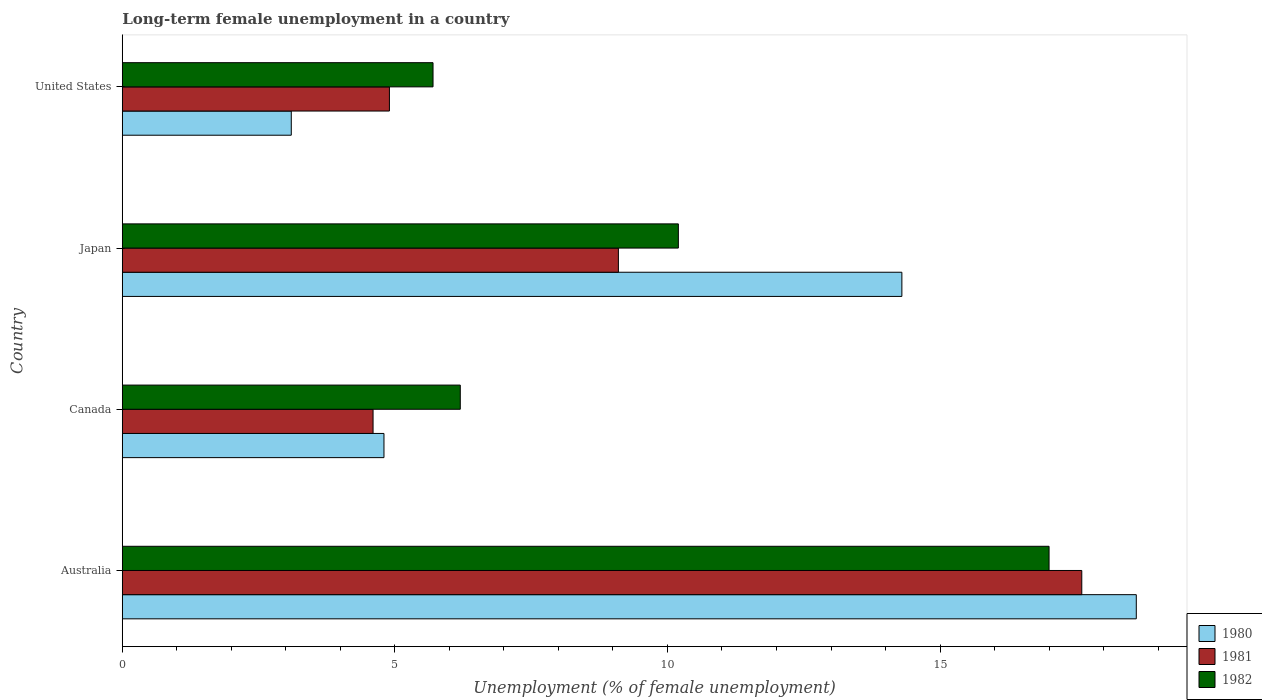Are the number of bars per tick equal to the number of legend labels?
Provide a short and direct response. Yes. Are the number of bars on each tick of the Y-axis equal?
Give a very brief answer. Yes. How many bars are there on the 2nd tick from the top?
Keep it short and to the point. 3. In how many cases, is the number of bars for a given country not equal to the number of legend labels?
Ensure brevity in your answer.  0. What is the percentage of long-term unemployed female population in 1980 in Canada?
Keep it short and to the point. 4.8. Across all countries, what is the maximum percentage of long-term unemployed female population in 1980?
Ensure brevity in your answer.  18.6. Across all countries, what is the minimum percentage of long-term unemployed female population in 1981?
Give a very brief answer. 4.6. In which country was the percentage of long-term unemployed female population in 1981 maximum?
Offer a terse response. Australia. What is the total percentage of long-term unemployed female population in 1981 in the graph?
Provide a succinct answer. 36.2. What is the difference between the percentage of long-term unemployed female population in 1981 in Australia and that in Japan?
Your answer should be compact. 8.5. What is the difference between the percentage of long-term unemployed female population in 1982 in United States and the percentage of long-term unemployed female population in 1980 in Australia?
Keep it short and to the point. -12.9. What is the average percentage of long-term unemployed female population in 1981 per country?
Give a very brief answer. 9.05. What is the difference between the percentage of long-term unemployed female population in 1981 and percentage of long-term unemployed female population in 1982 in Australia?
Provide a succinct answer. 0.6. In how many countries, is the percentage of long-term unemployed female population in 1981 greater than 10 %?
Keep it short and to the point. 1. What is the ratio of the percentage of long-term unemployed female population in 1980 in Australia to that in Japan?
Make the answer very short. 1.3. Is the percentage of long-term unemployed female population in 1980 in Canada less than that in Japan?
Make the answer very short. Yes. What is the difference between the highest and the second highest percentage of long-term unemployed female population in 1981?
Offer a very short reply. 8.5. What is the difference between the highest and the lowest percentage of long-term unemployed female population in 1981?
Keep it short and to the point. 13. In how many countries, is the percentage of long-term unemployed female population in 1982 greater than the average percentage of long-term unemployed female population in 1982 taken over all countries?
Provide a succinct answer. 2. Is the sum of the percentage of long-term unemployed female population in 1981 in Japan and United States greater than the maximum percentage of long-term unemployed female population in 1982 across all countries?
Your answer should be compact. No. Is it the case that in every country, the sum of the percentage of long-term unemployed female population in 1981 and percentage of long-term unemployed female population in 1982 is greater than the percentage of long-term unemployed female population in 1980?
Make the answer very short. Yes. Are all the bars in the graph horizontal?
Offer a terse response. Yes. How many countries are there in the graph?
Make the answer very short. 4. Where does the legend appear in the graph?
Give a very brief answer. Bottom right. How many legend labels are there?
Your answer should be very brief. 3. How are the legend labels stacked?
Your answer should be compact. Vertical. What is the title of the graph?
Ensure brevity in your answer.  Long-term female unemployment in a country. Does "2005" appear as one of the legend labels in the graph?
Provide a succinct answer. No. What is the label or title of the X-axis?
Your answer should be very brief. Unemployment (% of female unemployment). What is the Unemployment (% of female unemployment) of 1980 in Australia?
Offer a terse response. 18.6. What is the Unemployment (% of female unemployment) in 1981 in Australia?
Offer a very short reply. 17.6. What is the Unemployment (% of female unemployment) of 1980 in Canada?
Make the answer very short. 4.8. What is the Unemployment (% of female unemployment) of 1981 in Canada?
Give a very brief answer. 4.6. What is the Unemployment (% of female unemployment) of 1982 in Canada?
Provide a succinct answer. 6.2. What is the Unemployment (% of female unemployment) of 1980 in Japan?
Ensure brevity in your answer.  14.3. What is the Unemployment (% of female unemployment) in 1981 in Japan?
Your answer should be compact. 9.1. What is the Unemployment (% of female unemployment) of 1982 in Japan?
Keep it short and to the point. 10.2. What is the Unemployment (% of female unemployment) of 1980 in United States?
Your answer should be compact. 3.1. What is the Unemployment (% of female unemployment) in 1981 in United States?
Offer a very short reply. 4.9. What is the Unemployment (% of female unemployment) of 1982 in United States?
Your response must be concise. 5.7. Across all countries, what is the maximum Unemployment (% of female unemployment) of 1980?
Your answer should be very brief. 18.6. Across all countries, what is the maximum Unemployment (% of female unemployment) of 1981?
Give a very brief answer. 17.6. Across all countries, what is the minimum Unemployment (% of female unemployment) in 1980?
Give a very brief answer. 3.1. Across all countries, what is the minimum Unemployment (% of female unemployment) of 1981?
Provide a succinct answer. 4.6. Across all countries, what is the minimum Unemployment (% of female unemployment) in 1982?
Make the answer very short. 5.7. What is the total Unemployment (% of female unemployment) in 1980 in the graph?
Give a very brief answer. 40.8. What is the total Unemployment (% of female unemployment) of 1981 in the graph?
Your answer should be compact. 36.2. What is the total Unemployment (% of female unemployment) in 1982 in the graph?
Offer a terse response. 39.1. What is the difference between the Unemployment (% of female unemployment) in 1982 in Australia and that in United States?
Offer a terse response. 11.3. What is the difference between the Unemployment (% of female unemployment) of 1982 in Canada and that in Japan?
Provide a short and direct response. -4. What is the difference between the Unemployment (% of female unemployment) of 1982 in Canada and that in United States?
Your answer should be very brief. 0.5. What is the difference between the Unemployment (% of female unemployment) in 1981 in Japan and that in United States?
Provide a succinct answer. 4.2. What is the difference between the Unemployment (% of female unemployment) in 1982 in Japan and that in United States?
Offer a terse response. 4.5. What is the difference between the Unemployment (% of female unemployment) in 1980 in Australia and the Unemployment (% of female unemployment) in 1981 in Canada?
Provide a short and direct response. 14. What is the difference between the Unemployment (% of female unemployment) of 1980 in Australia and the Unemployment (% of female unemployment) of 1981 in Japan?
Provide a short and direct response. 9.5. What is the difference between the Unemployment (% of female unemployment) in 1981 in Australia and the Unemployment (% of female unemployment) in 1982 in Japan?
Your answer should be very brief. 7.4. What is the difference between the Unemployment (% of female unemployment) of 1980 in Australia and the Unemployment (% of female unemployment) of 1981 in United States?
Your answer should be very brief. 13.7. What is the difference between the Unemployment (% of female unemployment) in 1980 in Australia and the Unemployment (% of female unemployment) in 1982 in United States?
Your answer should be very brief. 12.9. What is the difference between the Unemployment (% of female unemployment) of 1981 in Australia and the Unemployment (% of female unemployment) of 1982 in United States?
Give a very brief answer. 11.9. What is the difference between the Unemployment (% of female unemployment) of 1980 in Canada and the Unemployment (% of female unemployment) of 1981 in Japan?
Ensure brevity in your answer.  -4.3. What is the difference between the Unemployment (% of female unemployment) in 1981 in Canada and the Unemployment (% of female unemployment) in 1982 in Japan?
Keep it short and to the point. -5.6. What is the difference between the Unemployment (% of female unemployment) in 1980 in Canada and the Unemployment (% of female unemployment) in 1981 in United States?
Keep it short and to the point. -0.1. What is the difference between the Unemployment (% of female unemployment) of 1981 in Canada and the Unemployment (% of female unemployment) of 1982 in United States?
Give a very brief answer. -1.1. What is the difference between the Unemployment (% of female unemployment) of 1980 in Japan and the Unemployment (% of female unemployment) of 1981 in United States?
Offer a terse response. 9.4. What is the difference between the Unemployment (% of female unemployment) in 1980 in Japan and the Unemployment (% of female unemployment) in 1982 in United States?
Ensure brevity in your answer.  8.6. What is the average Unemployment (% of female unemployment) of 1981 per country?
Your answer should be compact. 9.05. What is the average Unemployment (% of female unemployment) of 1982 per country?
Offer a terse response. 9.78. What is the difference between the Unemployment (% of female unemployment) of 1980 and Unemployment (% of female unemployment) of 1981 in Australia?
Your answer should be very brief. 1. What is the difference between the Unemployment (% of female unemployment) in 1980 and Unemployment (% of female unemployment) in 1981 in Canada?
Provide a succinct answer. 0.2. What is the difference between the Unemployment (% of female unemployment) of 1980 and Unemployment (% of female unemployment) of 1982 in Canada?
Keep it short and to the point. -1.4. What is the difference between the Unemployment (% of female unemployment) of 1981 and Unemployment (% of female unemployment) of 1982 in Canada?
Your answer should be compact. -1.6. What is the difference between the Unemployment (% of female unemployment) in 1980 and Unemployment (% of female unemployment) in 1981 in Japan?
Make the answer very short. 5.2. What is the difference between the Unemployment (% of female unemployment) in 1981 and Unemployment (% of female unemployment) in 1982 in Japan?
Offer a terse response. -1.1. What is the ratio of the Unemployment (% of female unemployment) of 1980 in Australia to that in Canada?
Ensure brevity in your answer.  3.88. What is the ratio of the Unemployment (% of female unemployment) of 1981 in Australia to that in Canada?
Your answer should be very brief. 3.83. What is the ratio of the Unemployment (% of female unemployment) in 1982 in Australia to that in Canada?
Give a very brief answer. 2.74. What is the ratio of the Unemployment (% of female unemployment) of 1980 in Australia to that in Japan?
Give a very brief answer. 1.3. What is the ratio of the Unemployment (% of female unemployment) in 1981 in Australia to that in Japan?
Provide a short and direct response. 1.93. What is the ratio of the Unemployment (% of female unemployment) of 1980 in Australia to that in United States?
Your response must be concise. 6. What is the ratio of the Unemployment (% of female unemployment) of 1981 in Australia to that in United States?
Offer a very short reply. 3.59. What is the ratio of the Unemployment (% of female unemployment) of 1982 in Australia to that in United States?
Offer a very short reply. 2.98. What is the ratio of the Unemployment (% of female unemployment) of 1980 in Canada to that in Japan?
Offer a terse response. 0.34. What is the ratio of the Unemployment (% of female unemployment) in 1981 in Canada to that in Japan?
Keep it short and to the point. 0.51. What is the ratio of the Unemployment (% of female unemployment) of 1982 in Canada to that in Japan?
Keep it short and to the point. 0.61. What is the ratio of the Unemployment (% of female unemployment) in 1980 in Canada to that in United States?
Your answer should be very brief. 1.55. What is the ratio of the Unemployment (% of female unemployment) in 1981 in Canada to that in United States?
Your answer should be very brief. 0.94. What is the ratio of the Unemployment (% of female unemployment) of 1982 in Canada to that in United States?
Make the answer very short. 1.09. What is the ratio of the Unemployment (% of female unemployment) in 1980 in Japan to that in United States?
Provide a succinct answer. 4.61. What is the ratio of the Unemployment (% of female unemployment) of 1981 in Japan to that in United States?
Ensure brevity in your answer.  1.86. What is the ratio of the Unemployment (% of female unemployment) in 1982 in Japan to that in United States?
Your answer should be very brief. 1.79. What is the difference between the highest and the second highest Unemployment (% of female unemployment) in 1980?
Provide a short and direct response. 4.3. What is the difference between the highest and the second highest Unemployment (% of female unemployment) of 1982?
Your answer should be compact. 6.8. What is the difference between the highest and the lowest Unemployment (% of female unemployment) of 1982?
Provide a succinct answer. 11.3. 